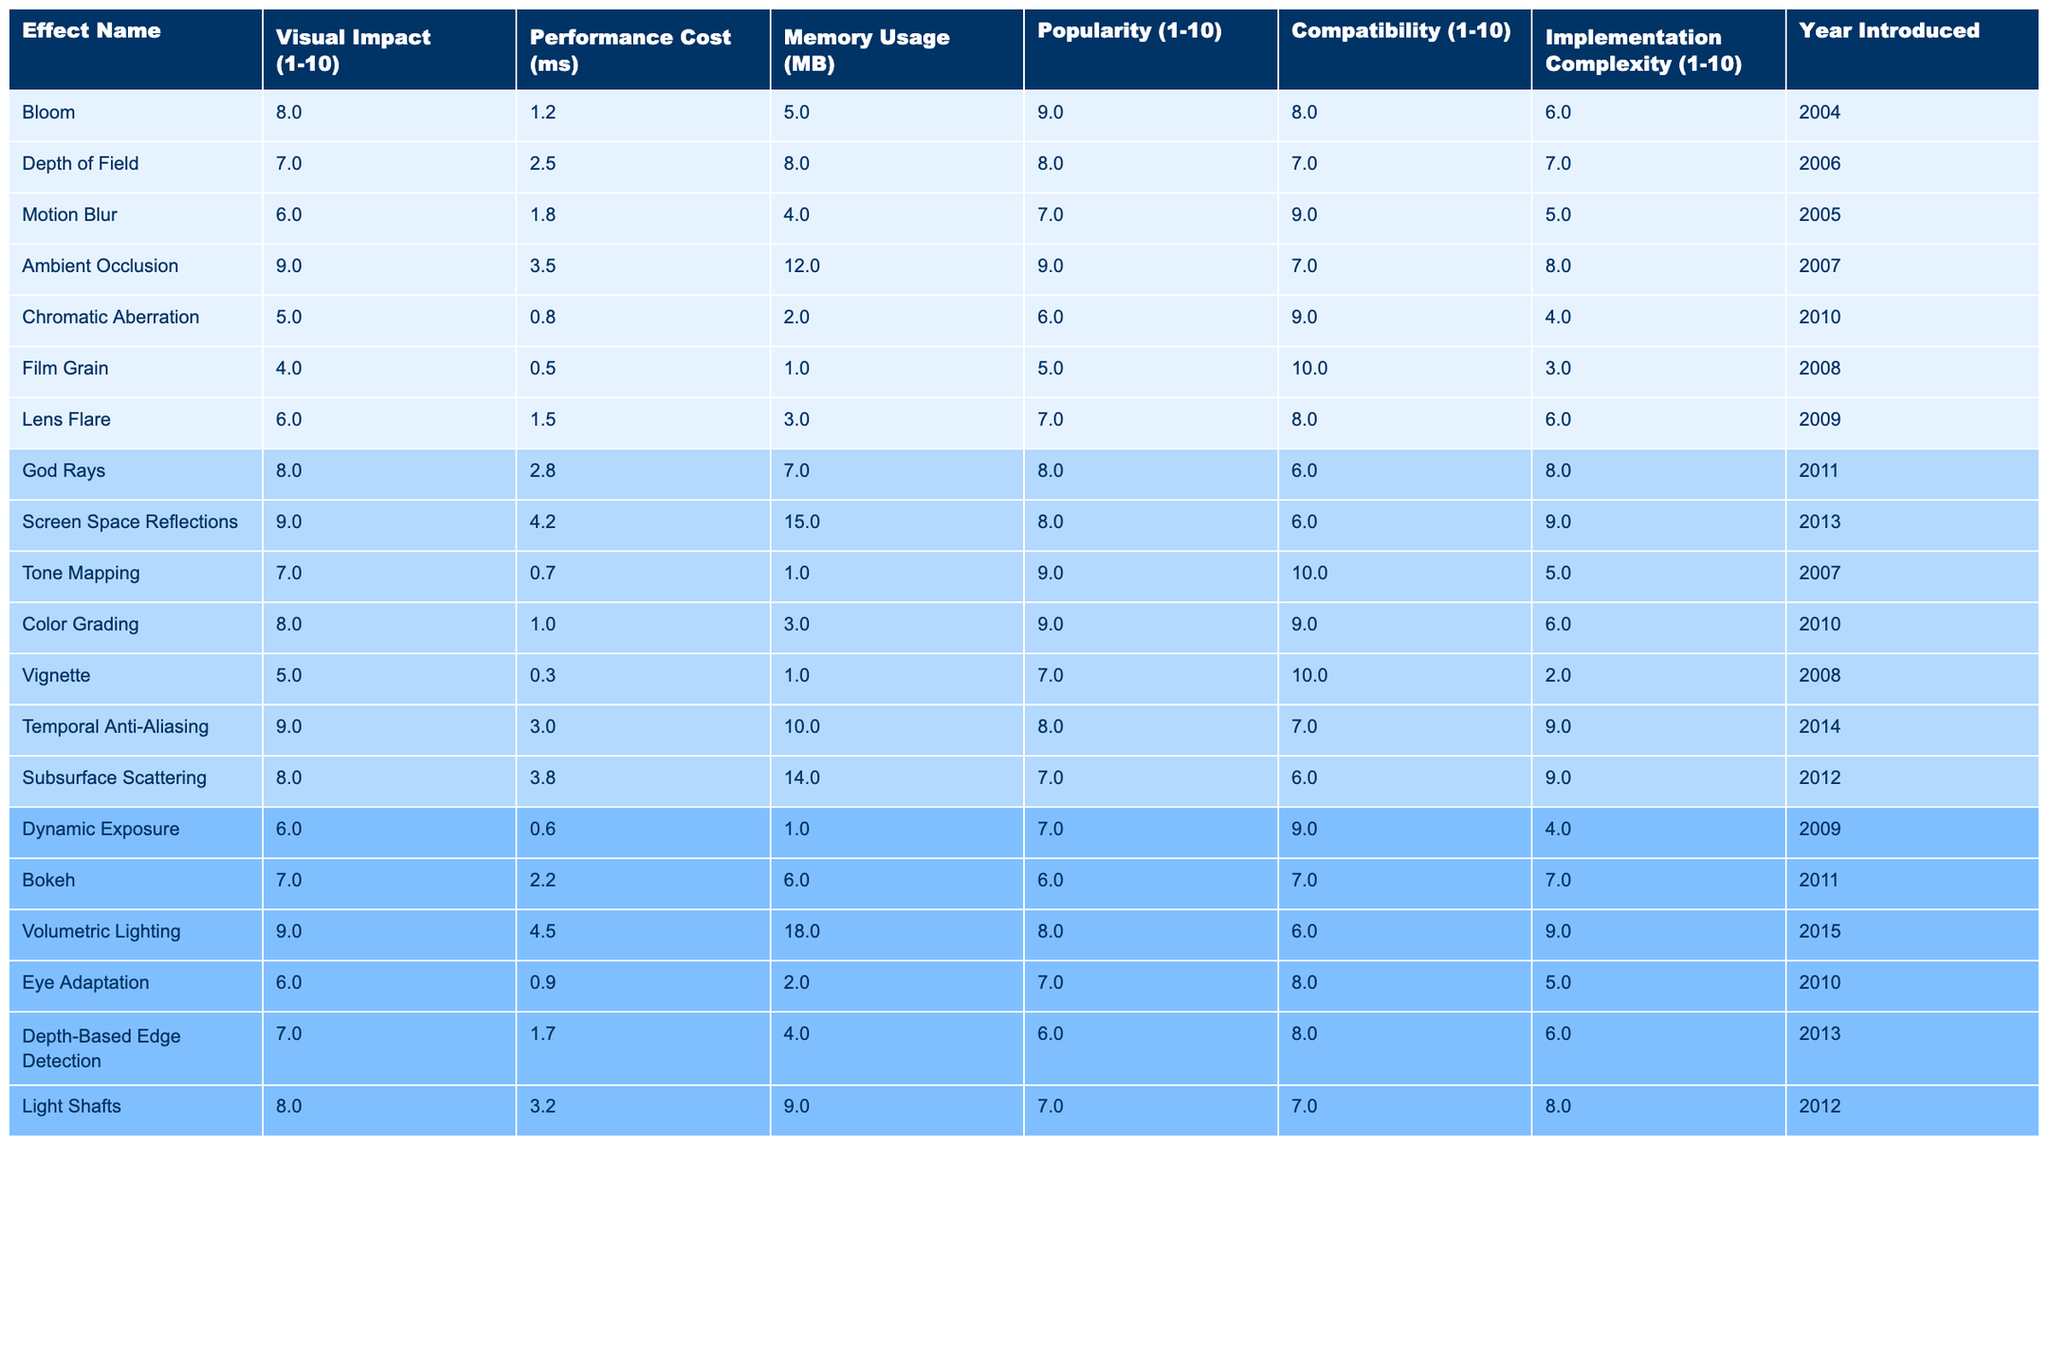What is the visual impact rating of Ambient Occlusion? The table shows that the visual impact rating for Ambient Occlusion is 9.
Answer: 9 Which effect has the highest memory usage? By reviewing the memory usage column, Screen Space Reflections has the highest memory usage at 15 MB.
Answer: 15 MB What is the average performance cost of Bloom and Lens Flare? First, we find the performance costs: Bloom has 1.2 ms and Lens Flare has 1.5 ms. The average is (1.2 + 1.5) / 2 = 1.35 ms.
Answer: 1.35 ms Is there any effect introduced in 2007 with a visual impact below 8? We check the Year Introduced and the Visual Impact for 2007 effects. Depth of Field has a visual impact of 7, so the answer is yes.
Answer: Yes What is the total performance cost of all effects that have a popularity rating of 9? The effects with a popularity rating of 9 are Bloom (1.2 ms), Ambient Occlusion (3.5 ms), Tone Mapping (0.7 ms), Color Grading (1.0 ms), and Volumetric Lighting (4.5 ms). The total performance cost is 1.2 + 3.5 + 0.7 + 1.0 + 4.5 = 12.9 ms.
Answer: 12.9 ms Which effect has the lowest visual impact and memory usage? By examining the table, Film Grain has the lowest visual impact of 4 and memory usage of 1 MB, making it the effect that meets both criteria.
Answer: Film Grain What effect was introduced in 2015 and has a performance cost higher than 4 ms? The only effect introduced in 2015 is Volumetric Lighting, which has a performance cost of 4.5 ms, satisfying the condition.
Answer: Volumetric Lighting Which effect has both the highest compatibility and implementation complexity? We analyze compatibility and implementation complexity. Color Grading has the highest compatibility of 9 and an implementation complexity of 6, but no effect has both high categories together; thus, the answer is none.
Answer: None How many effects have a visual impact score of 8 or higher and are compatible with 9? The effects that fit this requirement are Bloom, Ambient Occlusion, Tone Mapping, Color Grading, Temporal Anti-Aliasing, and Volumetric Lighting. The count is 6 effects.
Answer: 6 